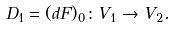Convert formula to latex. <formula><loc_0><loc_0><loc_500><loc_500>D _ { 1 } = ( d F ) _ { 0 } \colon V _ { 1 } \rightarrow V _ { 2 } .</formula> 